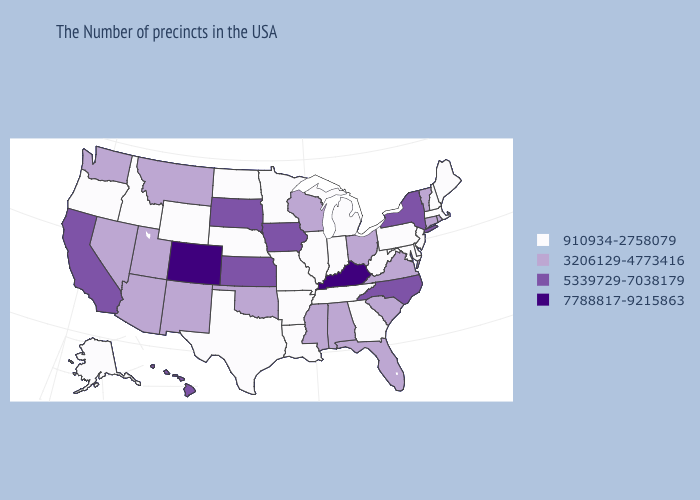What is the highest value in the USA?
Be succinct. 7788817-9215863. Which states have the highest value in the USA?
Answer briefly. Kentucky, Colorado. What is the value of Montana?
Quick response, please. 3206129-4773416. Does Ohio have the lowest value in the USA?
Quick response, please. No. What is the value of Connecticut?
Give a very brief answer. 3206129-4773416. What is the highest value in states that border Minnesota?
Be succinct. 5339729-7038179. Does Hawaii have a lower value than Colorado?
Quick response, please. Yes. Name the states that have a value in the range 7788817-9215863?
Concise answer only. Kentucky, Colorado. Name the states that have a value in the range 910934-2758079?
Give a very brief answer. Maine, Massachusetts, New Hampshire, New Jersey, Delaware, Maryland, Pennsylvania, West Virginia, Georgia, Michigan, Indiana, Tennessee, Illinois, Louisiana, Missouri, Arkansas, Minnesota, Nebraska, Texas, North Dakota, Wyoming, Idaho, Oregon, Alaska. Does New York have the highest value in the Northeast?
Give a very brief answer. Yes. What is the lowest value in the South?
Quick response, please. 910934-2758079. What is the value of North Carolina?
Write a very short answer. 5339729-7038179. How many symbols are there in the legend?
Write a very short answer. 4. Does the first symbol in the legend represent the smallest category?
Answer briefly. Yes. Does Massachusetts have the same value as Rhode Island?
Answer briefly. No. 